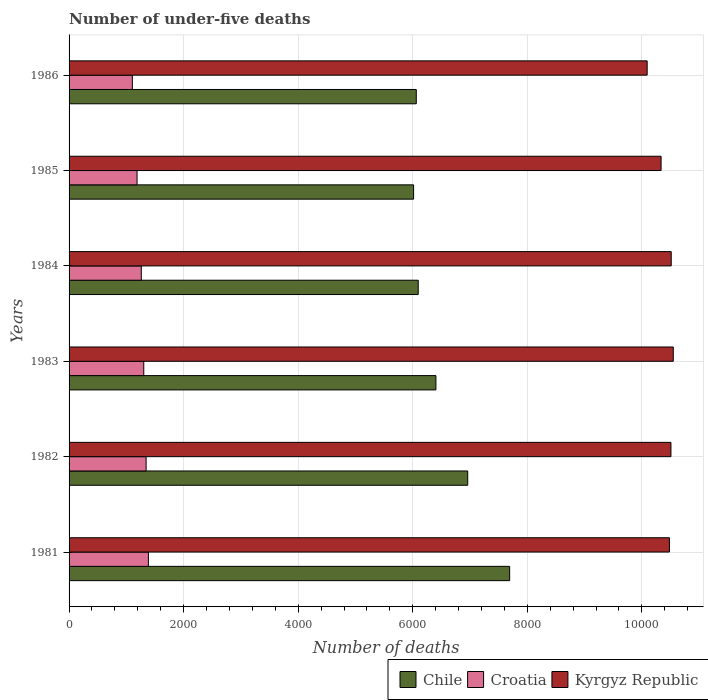Are the number of bars per tick equal to the number of legend labels?
Your answer should be very brief. Yes. Are the number of bars on each tick of the Y-axis equal?
Offer a terse response. Yes. How many bars are there on the 4th tick from the top?
Provide a succinct answer. 3. In how many cases, is the number of bars for a given year not equal to the number of legend labels?
Your response must be concise. 0. What is the number of under-five deaths in Chile in 1982?
Provide a short and direct response. 6960. Across all years, what is the maximum number of under-five deaths in Chile?
Your answer should be very brief. 7692. Across all years, what is the minimum number of under-five deaths in Chile?
Your response must be concise. 6015. In which year was the number of under-five deaths in Chile maximum?
Make the answer very short. 1981. What is the total number of under-five deaths in Chile in the graph?
Offer a terse response. 3.92e+04. What is the difference between the number of under-five deaths in Kyrgyz Republic in 1981 and the number of under-five deaths in Croatia in 1982?
Provide a succinct answer. 9137. What is the average number of under-five deaths in Croatia per year?
Ensure brevity in your answer.  1264.5. In the year 1984, what is the difference between the number of under-five deaths in Kyrgyz Republic and number of under-five deaths in Croatia?
Offer a very short reply. 9252. What is the ratio of the number of under-five deaths in Croatia in 1981 to that in 1986?
Offer a very short reply. 1.25. Is the number of under-five deaths in Croatia in 1981 less than that in 1984?
Your answer should be very brief. No. What is the difference between the highest and the lowest number of under-five deaths in Croatia?
Your answer should be very brief. 280. In how many years, is the number of under-five deaths in Chile greater than the average number of under-five deaths in Chile taken over all years?
Your answer should be very brief. 2. Is the sum of the number of under-five deaths in Chile in 1981 and 1983 greater than the maximum number of under-five deaths in Kyrgyz Republic across all years?
Keep it short and to the point. Yes. What does the 2nd bar from the top in 1986 represents?
Provide a succinct answer. Croatia. What does the 2nd bar from the bottom in 1985 represents?
Give a very brief answer. Croatia. Is it the case that in every year, the sum of the number of under-five deaths in Kyrgyz Republic and number of under-five deaths in Croatia is greater than the number of under-five deaths in Chile?
Provide a short and direct response. Yes. How many years are there in the graph?
Keep it short and to the point. 6. What is the difference between two consecutive major ticks on the X-axis?
Offer a very short reply. 2000. Are the values on the major ticks of X-axis written in scientific E-notation?
Your response must be concise. No. Does the graph contain any zero values?
Provide a succinct answer. No. How many legend labels are there?
Your answer should be compact. 3. What is the title of the graph?
Your answer should be compact. Number of under-five deaths. Does "Poland" appear as one of the legend labels in the graph?
Ensure brevity in your answer.  No. What is the label or title of the X-axis?
Make the answer very short. Number of deaths. What is the Number of deaths in Chile in 1981?
Offer a very short reply. 7692. What is the Number of deaths of Croatia in 1981?
Ensure brevity in your answer.  1385. What is the Number of deaths of Kyrgyz Republic in 1981?
Offer a terse response. 1.05e+04. What is the Number of deaths in Chile in 1982?
Your answer should be very brief. 6960. What is the Number of deaths in Croatia in 1982?
Your answer should be very brief. 1345. What is the Number of deaths in Kyrgyz Republic in 1982?
Make the answer very short. 1.05e+04. What is the Number of deaths of Chile in 1983?
Ensure brevity in your answer.  6405. What is the Number of deaths in Croatia in 1983?
Offer a very short reply. 1304. What is the Number of deaths in Kyrgyz Republic in 1983?
Offer a terse response. 1.05e+04. What is the Number of deaths in Chile in 1984?
Your answer should be very brief. 6096. What is the Number of deaths in Croatia in 1984?
Offer a terse response. 1261. What is the Number of deaths in Kyrgyz Republic in 1984?
Give a very brief answer. 1.05e+04. What is the Number of deaths in Chile in 1985?
Give a very brief answer. 6015. What is the Number of deaths of Croatia in 1985?
Your response must be concise. 1187. What is the Number of deaths in Kyrgyz Republic in 1985?
Your response must be concise. 1.03e+04. What is the Number of deaths in Chile in 1986?
Offer a terse response. 6062. What is the Number of deaths in Croatia in 1986?
Provide a short and direct response. 1105. What is the Number of deaths in Kyrgyz Republic in 1986?
Provide a succinct answer. 1.01e+04. Across all years, what is the maximum Number of deaths of Chile?
Offer a very short reply. 7692. Across all years, what is the maximum Number of deaths in Croatia?
Offer a very short reply. 1385. Across all years, what is the maximum Number of deaths of Kyrgyz Republic?
Offer a very short reply. 1.05e+04. Across all years, what is the minimum Number of deaths in Chile?
Provide a short and direct response. 6015. Across all years, what is the minimum Number of deaths of Croatia?
Ensure brevity in your answer.  1105. Across all years, what is the minimum Number of deaths in Kyrgyz Republic?
Give a very brief answer. 1.01e+04. What is the total Number of deaths in Chile in the graph?
Offer a terse response. 3.92e+04. What is the total Number of deaths in Croatia in the graph?
Your answer should be very brief. 7587. What is the total Number of deaths in Kyrgyz Republic in the graph?
Ensure brevity in your answer.  6.25e+04. What is the difference between the Number of deaths of Chile in 1981 and that in 1982?
Your answer should be compact. 732. What is the difference between the Number of deaths in Croatia in 1981 and that in 1982?
Ensure brevity in your answer.  40. What is the difference between the Number of deaths in Kyrgyz Republic in 1981 and that in 1982?
Provide a short and direct response. -26. What is the difference between the Number of deaths in Chile in 1981 and that in 1983?
Make the answer very short. 1287. What is the difference between the Number of deaths in Croatia in 1981 and that in 1983?
Your answer should be very brief. 81. What is the difference between the Number of deaths in Kyrgyz Republic in 1981 and that in 1983?
Your answer should be compact. -67. What is the difference between the Number of deaths of Chile in 1981 and that in 1984?
Your answer should be compact. 1596. What is the difference between the Number of deaths in Croatia in 1981 and that in 1984?
Your response must be concise. 124. What is the difference between the Number of deaths in Kyrgyz Republic in 1981 and that in 1984?
Ensure brevity in your answer.  -31. What is the difference between the Number of deaths of Chile in 1981 and that in 1985?
Your response must be concise. 1677. What is the difference between the Number of deaths in Croatia in 1981 and that in 1985?
Your response must be concise. 198. What is the difference between the Number of deaths of Kyrgyz Republic in 1981 and that in 1985?
Your answer should be very brief. 146. What is the difference between the Number of deaths in Chile in 1981 and that in 1986?
Your answer should be very brief. 1630. What is the difference between the Number of deaths of Croatia in 1981 and that in 1986?
Keep it short and to the point. 280. What is the difference between the Number of deaths of Kyrgyz Republic in 1981 and that in 1986?
Offer a terse response. 389. What is the difference between the Number of deaths in Chile in 1982 and that in 1983?
Provide a succinct answer. 555. What is the difference between the Number of deaths of Croatia in 1982 and that in 1983?
Offer a terse response. 41. What is the difference between the Number of deaths in Kyrgyz Republic in 1982 and that in 1983?
Provide a succinct answer. -41. What is the difference between the Number of deaths in Chile in 1982 and that in 1984?
Keep it short and to the point. 864. What is the difference between the Number of deaths in Croatia in 1982 and that in 1984?
Your answer should be compact. 84. What is the difference between the Number of deaths of Kyrgyz Republic in 1982 and that in 1984?
Your response must be concise. -5. What is the difference between the Number of deaths in Chile in 1982 and that in 1985?
Keep it short and to the point. 945. What is the difference between the Number of deaths of Croatia in 1982 and that in 1985?
Ensure brevity in your answer.  158. What is the difference between the Number of deaths of Kyrgyz Republic in 1982 and that in 1985?
Make the answer very short. 172. What is the difference between the Number of deaths of Chile in 1982 and that in 1986?
Make the answer very short. 898. What is the difference between the Number of deaths in Croatia in 1982 and that in 1986?
Provide a succinct answer. 240. What is the difference between the Number of deaths of Kyrgyz Republic in 1982 and that in 1986?
Ensure brevity in your answer.  415. What is the difference between the Number of deaths in Chile in 1983 and that in 1984?
Your answer should be compact. 309. What is the difference between the Number of deaths of Croatia in 1983 and that in 1984?
Keep it short and to the point. 43. What is the difference between the Number of deaths of Kyrgyz Republic in 1983 and that in 1984?
Ensure brevity in your answer.  36. What is the difference between the Number of deaths in Chile in 1983 and that in 1985?
Ensure brevity in your answer.  390. What is the difference between the Number of deaths of Croatia in 1983 and that in 1985?
Give a very brief answer. 117. What is the difference between the Number of deaths of Kyrgyz Republic in 1983 and that in 1985?
Your response must be concise. 213. What is the difference between the Number of deaths in Chile in 1983 and that in 1986?
Your answer should be compact. 343. What is the difference between the Number of deaths of Croatia in 1983 and that in 1986?
Provide a short and direct response. 199. What is the difference between the Number of deaths in Kyrgyz Republic in 1983 and that in 1986?
Provide a short and direct response. 456. What is the difference between the Number of deaths in Chile in 1984 and that in 1985?
Provide a short and direct response. 81. What is the difference between the Number of deaths in Kyrgyz Republic in 1984 and that in 1985?
Offer a terse response. 177. What is the difference between the Number of deaths of Croatia in 1984 and that in 1986?
Ensure brevity in your answer.  156. What is the difference between the Number of deaths of Kyrgyz Republic in 1984 and that in 1986?
Provide a succinct answer. 420. What is the difference between the Number of deaths of Chile in 1985 and that in 1986?
Your response must be concise. -47. What is the difference between the Number of deaths in Kyrgyz Republic in 1985 and that in 1986?
Your response must be concise. 243. What is the difference between the Number of deaths in Chile in 1981 and the Number of deaths in Croatia in 1982?
Provide a short and direct response. 6347. What is the difference between the Number of deaths of Chile in 1981 and the Number of deaths of Kyrgyz Republic in 1982?
Your response must be concise. -2816. What is the difference between the Number of deaths in Croatia in 1981 and the Number of deaths in Kyrgyz Republic in 1982?
Offer a very short reply. -9123. What is the difference between the Number of deaths in Chile in 1981 and the Number of deaths in Croatia in 1983?
Provide a succinct answer. 6388. What is the difference between the Number of deaths of Chile in 1981 and the Number of deaths of Kyrgyz Republic in 1983?
Ensure brevity in your answer.  -2857. What is the difference between the Number of deaths in Croatia in 1981 and the Number of deaths in Kyrgyz Republic in 1983?
Offer a terse response. -9164. What is the difference between the Number of deaths of Chile in 1981 and the Number of deaths of Croatia in 1984?
Keep it short and to the point. 6431. What is the difference between the Number of deaths in Chile in 1981 and the Number of deaths in Kyrgyz Republic in 1984?
Offer a very short reply. -2821. What is the difference between the Number of deaths of Croatia in 1981 and the Number of deaths of Kyrgyz Republic in 1984?
Keep it short and to the point. -9128. What is the difference between the Number of deaths in Chile in 1981 and the Number of deaths in Croatia in 1985?
Make the answer very short. 6505. What is the difference between the Number of deaths of Chile in 1981 and the Number of deaths of Kyrgyz Republic in 1985?
Offer a terse response. -2644. What is the difference between the Number of deaths of Croatia in 1981 and the Number of deaths of Kyrgyz Republic in 1985?
Give a very brief answer. -8951. What is the difference between the Number of deaths in Chile in 1981 and the Number of deaths in Croatia in 1986?
Ensure brevity in your answer.  6587. What is the difference between the Number of deaths of Chile in 1981 and the Number of deaths of Kyrgyz Republic in 1986?
Your answer should be very brief. -2401. What is the difference between the Number of deaths in Croatia in 1981 and the Number of deaths in Kyrgyz Republic in 1986?
Offer a terse response. -8708. What is the difference between the Number of deaths of Chile in 1982 and the Number of deaths of Croatia in 1983?
Provide a succinct answer. 5656. What is the difference between the Number of deaths of Chile in 1982 and the Number of deaths of Kyrgyz Republic in 1983?
Keep it short and to the point. -3589. What is the difference between the Number of deaths in Croatia in 1982 and the Number of deaths in Kyrgyz Republic in 1983?
Provide a short and direct response. -9204. What is the difference between the Number of deaths of Chile in 1982 and the Number of deaths of Croatia in 1984?
Provide a short and direct response. 5699. What is the difference between the Number of deaths of Chile in 1982 and the Number of deaths of Kyrgyz Republic in 1984?
Your response must be concise. -3553. What is the difference between the Number of deaths in Croatia in 1982 and the Number of deaths in Kyrgyz Republic in 1984?
Make the answer very short. -9168. What is the difference between the Number of deaths of Chile in 1982 and the Number of deaths of Croatia in 1985?
Provide a succinct answer. 5773. What is the difference between the Number of deaths in Chile in 1982 and the Number of deaths in Kyrgyz Republic in 1985?
Your answer should be compact. -3376. What is the difference between the Number of deaths of Croatia in 1982 and the Number of deaths of Kyrgyz Republic in 1985?
Make the answer very short. -8991. What is the difference between the Number of deaths in Chile in 1982 and the Number of deaths in Croatia in 1986?
Give a very brief answer. 5855. What is the difference between the Number of deaths in Chile in 1982 and the Number of deaths in Kyrgyz Republic in 1986?
Your answer should be very brief. -3133. What is the difference between the Number of deaths of Croatia in 1982 and the Number of deaths of Kyrgyz Republic in 1986?
Offer a very short reply. -8748. What is the difference between the Number of deaths in Chile in 1983 and the Number of deaths in Croatia in 1984?
Provide a short and direct response. 5144. What is the difference between the Number of deaths of Chile in 1983 and the Number of deaths of Kyrgyz Republic in 1984?
Your response must be concise. -4108. What is the difference between the Number of deaths of Croatia in 1983 and the Number of deaths of Kyrgyz Republic in 1984?
Offer a terse response. -9209. What is the difference between the Number of deaths of Chile in 1983 and the Number of deaths of Croatia in 1985?
Your answer should be compact. 5218. What is the difference between the Number of deaths in Chile in 1983 and the Number of deaths in Kyrgyz Republic in 1985?
Offer a very short reply. -3931. What is the difference between the Number of deaths of Croatia in 1983 and the Number of deaths of Kyrgyz Republic in 1985?
Your answer should be compact. -9032. What is the difference between the Number of deaths of Chile in 1983 and the Number of deaths of Croatia in 1986?
Make the answer very short. 5300. What is the difference between the Number of deaths in Chile in 1983 and the Number of deaths in Kyrgyz Republic in 1986?
Make the answer very short. -3688. What is the difference between the Number of deaths of Croatia in 1983 and the Number of deaths of Kyrgyz Republic in 1986?
Your answer should be compact. -8789. What is the difference between the Number of deaths in Chile in 1984 and the Number of deaths in Croatia in 1985?
Ensure brevity in your answer.  4909. What is the difference between the Number of deaths of Chile in 1984 and the Number of deaths of Kyrgyz Republic in 1985?
Your response must be concise. -4240. What is the difference between the Number of deaths of Croatia in 1984 and the Number of deaths of Kyrgyz Republic in 1985?
Give a very brief answer. -9075. What is the difference between the Number of deaths in Chile in 1984 and the Number of deaths in Croatia in 1986?
Provide a short and direct response. 4991. What is the difference between the Number of deaths of Chile in 1984 and the Number of deaths of Kyrgyz Republic in 1986?
Your answer should be very brief. -3997. What is the difference between the Number of deaths of Croatia in 1984 and the Number of deaths of Kyrgyz Republic in 1986?
Provide a succinct answer. -8832. What is the difference between the Number of deaths of Chile in 1985 and the Number of deaths of Croatia in 1986?
Give a very brief answer. 4910. What is the difference between the Number of deaths in Chile in 1985 and the Number of deaths in Kyrgyz Republic in 1986?
Ensure brevity in your answer.  -4078. What is the difference between the Number of deaths of Croatia in 1985 and the Number of deaths of Kyrgyz Republic in 1986?
Keep it short and to the point. -8906. What is the average Number of deaths of Chile per year?
Give a very brief answer. 6538.33. What is the average Number of deaths of Croatia per year?
Make the answer very short. 1264.5. What is the average Number of deaths in Kyrgyz Republic per year?
Offer a very short reply. 1.04e+04. In the year 1981, what is the difference between the Number of deaths in Chile and Number of deaths in Croatia?
Your response must be concise. 6307. In the year 1981, what is the difference between the Number of deaths in Chile and Number of deaths in Kyrgyz Republic?
Provide a succinct answer. -2790. In the year 1981, what is the difference between the Number of deaths of Croatia and Number of deaths of Kyrgyz Republic?
Your response must be concise. -9097. In the year 1982, what is the difference between the Number of deaths in Chile and Number of deaths in Croatia?
Make the answer very short. 5615. In the year 1982, what is the difference between the Number of deaths in Chile and Number of deaths in Kyrgyz Republic?
Your response must be concise. -3548. In the year 1982, what is the difference between the Number of deaths in Croatia and Number of deaths in Kyrgyz Republic?
Make the answer very short. -9163. In the year 1983, what is the difference between the Number of deaths of Chile and Number of deaths of Croatia?
Provide a succinct answer. 5101. In the year 1983, what is the difference between the Number of deaths of Chile and Number of deaths of Kyrgyz Republic?
Provide a short and direct response. -4144. In the year 1983, what is the difference between the Number of deaths of Croatia and Number of deaths of Kyrgyz Republic?
Offer a very short reply. -9245. In the year 1984, what is the difference between the Number of deaths of Chile and Number of deaths of Croatia?
Your answer should be very brief. 4835. In the year 1984, what is the difference between the Number of deaths of Chile and Number of deaths of Kyrgyz Republic?
Provide a succinct answer. -4417. In the year 1984, what is the difference between the Number of deaths in Croatia and Number of deaths in Kyrgyz Republic?
Offer a terse response. -9252. In the year 1985, what is the difference between the Number of deaths of Chile and Number of deaths of Croatia?
Give a very brief answer. 4828. In the year 1985, what is the difference between the Number of deaths of Chile and Number of deaths of Kyrgyz Republic?
Your response must be concise. -4321. In the year 1985, what is the difference between the Number of deaths in Croatia and Number of deaths in Kyrgyz Republic?
Ensure brevity in your answer.  -9149. In the year 1986, what is the difference between the Number of deaths of Chile and Number of deaths of Croatia?
Your answer should be compact. 4957. In the year 1986, what is the difference between the Number of deaths in Chile and Number of deaths in Kyrgyz Republic?
Ensure brevity in your answer.  -4031. In the year 1986, what is the difference between the Number of deaths of Croatia and Number of deaths of Kyrgyz Republic?
Ensure brevity in your answer.  -8988. What is the ratio of the Number of deaths of Chile in 1981 to that in 1982?
Your response must be concise. 1.11. What is the ratio of the Number of deaths of Croatia in 1981 to that in 1982?
Provide a short and direct response. 1.03. What is the ratio of the Number of deaths of Kyrgyz Republic in 1981 to that in 1982?
Keep it short and to the point. 1. What is the ratio of the Number of deaths in Chile in 1981 to that in 1983?
Ensure brevity in your answer.  1.2. What is the ratio of the Number of deaths in Croatia in 1981 to that in 1983?
Offer a very short reply. 1.06. What is the ratio of the Number of deaths in Kyrgyz Republic in 1981 to that in 1983?
Give a very brief answer. 0.99. What is the ratio of the Number of deaths of Chile in 1981 to that in 1984?
Offer a terse response. 1.26. What is the ratio of the Number of deaths of Croatia in 1981 to that in 1984?
Keep it short and to the point. 1.1. What is the ratio of the Number of deaths in Kyrgyz Republic in 1981 to that in 1984?
Make the answer very short. 1. What is the ratio of the Number of deaths in Chile in 1981 to that in 1985?
Your answer should be compact. 1.28. What is the ratio of the Number of deaths in Croatia in 1981 to that in 1985?
Your answer should be compact. 1.17. What is the ratio of the Number of deaths in Kyrgyz Republic in 1981 to that in 1985?
Offer a very short reply. 1.01. What is the ratio of the Number of deaths of Chile in 1981 to that in 1986?
Give a very brief answer. 1.27. What is the ratio of the Number of deaths of Croatia in 1981 to that in 1986?
Make the answer very short. 1.25. What is the ratio of the Number of deaths of Kyrgyz Republic in 1981 to that in 1986?
Your answer should be very brief. 1.04. What is the ratio of the Number of deaths of Chile in 1982 to that in 1983?
Ensure brevity in your answer.  1.09. What is the ratio of the Number of deaths in Croatia in 1982 to that in 1983?
Make the answer very short. 1.03. What is the ratio of the Number of deaths of Kyrgyz Republic in 1982 to that in 1983?
Your answer should be compact. 1. What is the ratio of the Number of deaths in Chile in 1982 to that in 1984?
Give a very brief answer. 1.14. What is the ratio of the Number of deaths of Croatia in 1982 to that in 1984?
Your answer should be compact. 1.07. What is the ratio of the Number of deaths of Kyrgyz Republic in 1982 to that in 1984?
Offer a very short reply. 1. What is the ratio of the Number of deaths of Chile in 1982 to that in 1985?
Keep it short and to the point. 1.16. What is the ratio of the Number of deaths of Croatia in 1982 to that in 1985?
Make the answer very short. 1.13. What is the ratio of the Number of deaths in Kyrgyz Republic in 1982 to that in 1985?
Ensure brevity in your answer.  1.02. What is the ratio of the Number of deaths in Chile in 1982 to that in 1986?
Make the answer very short. 1.15. What is the ratio of the Number of deaths of Croatia in 1982 to that in 1986?
Keep it short and to the point. 1.22. What is the ratio of the Number of deaths in Kyrgyz Republic in 1982 to that in 1986?
Provide a succinct answer. 1.04. What is the ratio of the Number of deaths in Chile in 1983 to that in 1984?
Ensure brevity in your answer.  1.05. What is the ratio of the Number of deaths of Croatia in 1983 to that in 1984?
Provide a short and direct response. 1.03. What is the ratio of the Number of deaths in Kyrgyz Republic in 1983 to that in 1984?
Your answer should be compact. 1. What is the ratio of the Number of deaths in Chile in 1983 to that in 1985?
Your answer should be very brief. 1.06. What is the ratio of the Number of deaths of Croatia in 1983 to that in 1985?
Give a very brief answer. 1.1. What is the ratio of the Number of deaths of Kyrgyz Republic in 1983 to that in 1985?
Your answer should be compact. 1.02. What is the ratio of the Number of deaths in Chile in 1983 to that in 1986?
Your answer should be very brief. 1.06. What is the ratio of the Number of deaths in Croatia in 1983 to that in 1986?
Provide a short and direct response. 1.18. What is the ratio of the Number of deaths in Kyrgyz Republic in 1983 to that in 1986?
Ensure brevity in your answer.  1.05. What is the ratio of the Number of deaths of Chile in 1984 to that in 1985?
Your response must be concise. 1.01. What is the ratio of the Number of deaths in Croatia in 1984 to that in 1985?
Your response must be concise. 1.06. What is the ratio of the Number of deaths of Kyrgyz Republic in 1984 to that in 1985?
Offer a terse response. 1.02. What is the ratio of the Number of deaths of Chile in 1984 to that in 1986?
Offer a terse response. 1.01. What is the ratio of the Number of deaths in Croatia in 1984 to that in 1986?
Ensure brevity in your answer.  1.14. What is the ratio of the Number of deaths in Kyrgyz Republic in 1984 to that in 1986?
Ensure brevity in your answer.  1.04. What is the ratio of the Number of deaths in Chile in 1985 to that in 1986?
Provide a short and direct response. 0.99. What is the ratio of the Number of deaths of Croatia in 1985 to that in 1986?
Keep it short and to the point. 1.07. What is the ratio of the Number of deaths in Kyrgyz Republic in 1985 to that in 1986?
Your answer should be very brief. 1.02. What is the difference between the highest and the second highest Number of deaths of Chile?
Keep it short and to the point. 732. What is the difference between the highest and the lowest Number of deaths of Chile?
Your answer should be compact. 1677. What is the difference between the highest and the lowest Number of deaths in Croatia?
Ensure brevity in your answer.  280. What is the difference between the highest and the lowest Number of deaths in Kyrgyz Republic?
Give a very brief answer. 456. 